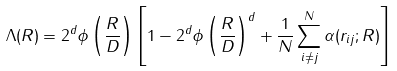Convert formula to latex. <formula><loc_0><loc_0><loc_500><loc_500>\Lambda ( R ) = 2 ^ { d } \phi \left ( \frac { R } { D } \right ) \left [ 1 - 2 ^ { d } \phi \left ( \frac { R } { D } \right ) ^ { d } + \frac { 1 } { N } \sum _ { i \neq j } ^ { N } \alpha ( r _ { i j } ; R ) \right ]</formula> 